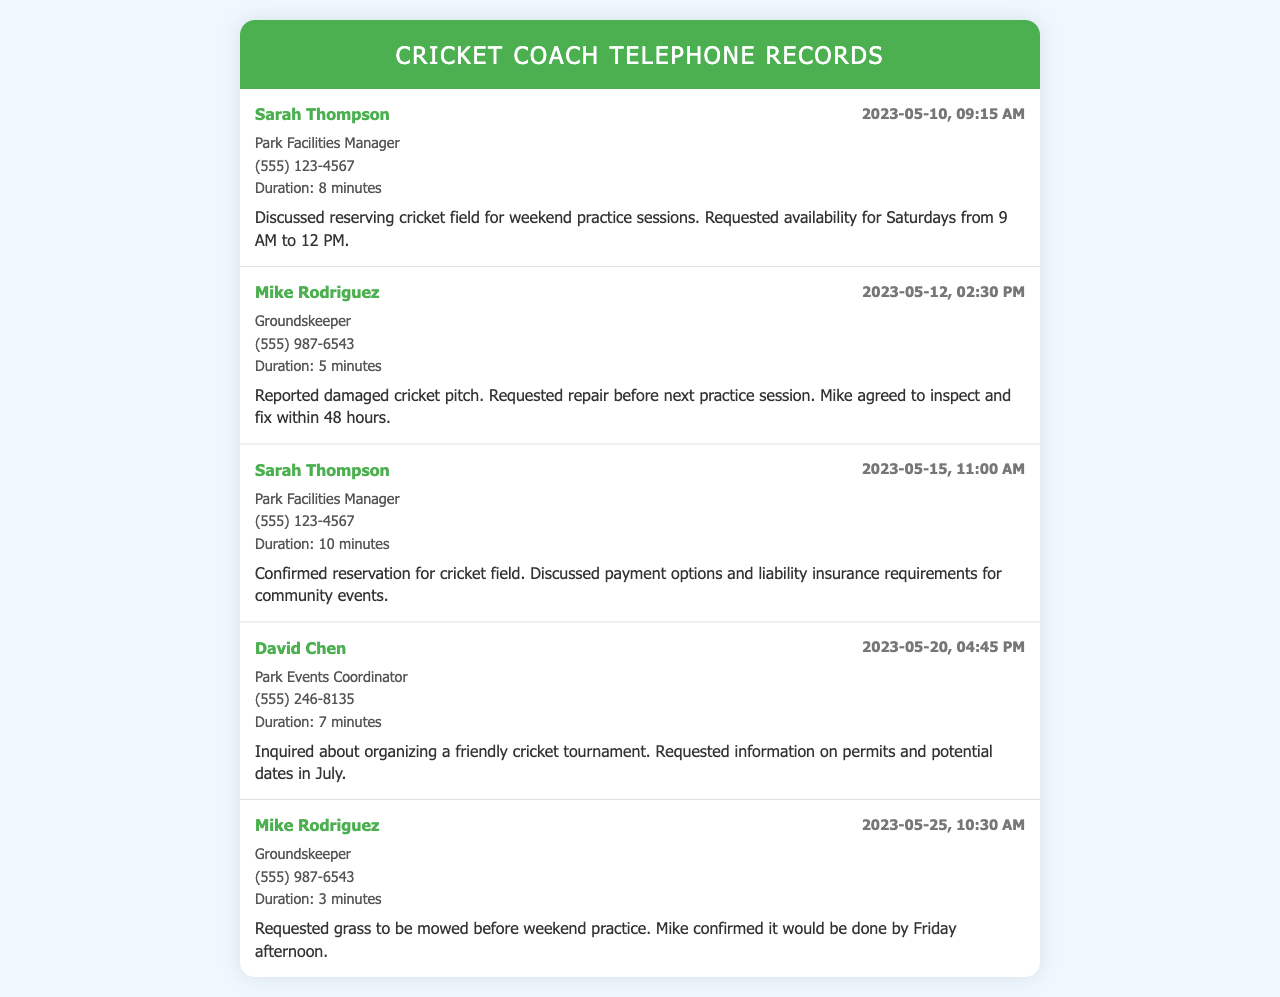What is the name of the Park Facilities Manager? The Park Facilities Manager is mentioned as Sarah Thompson in the records.
Answer: Sarah Thompson When was the cricket pitch reported damaged? The cricket pitch damage was reported during a call on May 12, 2023.
Answer: May 12, 2023 What was discussed during the call on May 15, 2023? The call on May 15, 2023, included confirmation of the cricket field reservation and payment options.
Answer: Reservation confirmation How long was the conversation with David Chen? The duration of the conversation with David Chen was 7 minutes.
Answer: 7 minutes Who agreed to inspect the cricket pitch? Mike Rodriguez, the Groundskeeper, agreed to inspect the cricket pitch.
Answer: Mike Rodriguez What date was the cricket field reserved? The cricket field reservation was confirmed on May 15, 2023.
Answer: May 15, 2023 How many minutes did the call with Sarah Thompson on May 10 last? The call on May 10 lasted for 8 minutes.
Answer: 8 minutes What was requested before the weekend practice sessions? Grass mowing was requested before the weekend practice sessions.
Answer: Grass mowing When did Mike Rodriguez confirm the grass would be mowed? Mike confirmed that the grass would be mowed by Friday afternoon; however, the date wasn't specified in that call.
Answer: By Friday afternoon 